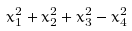<formula> <loc_0><loc_0><loc_500><loc_500>x ^ { 2 } _ { 1 } + x ^ { 2 } _ { 2 } + x ^ { 2 } _ { 3 } - x ^ { 2 } _ { 4 }</formula> 